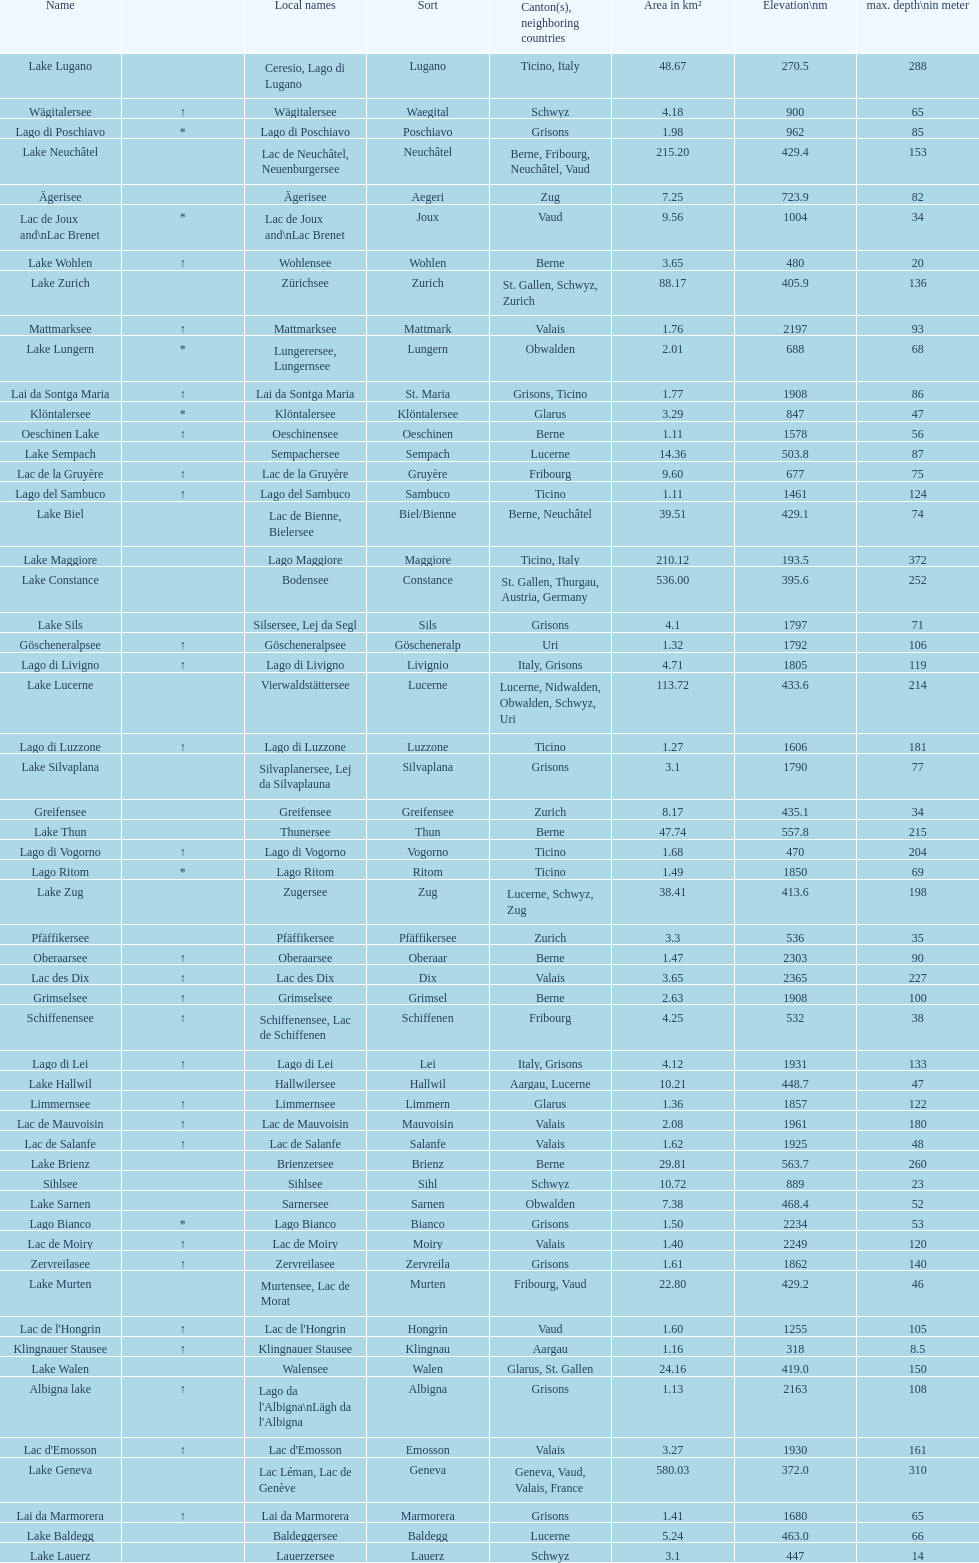What's the total max depth of lake geneva and lake constance combined? 562. 